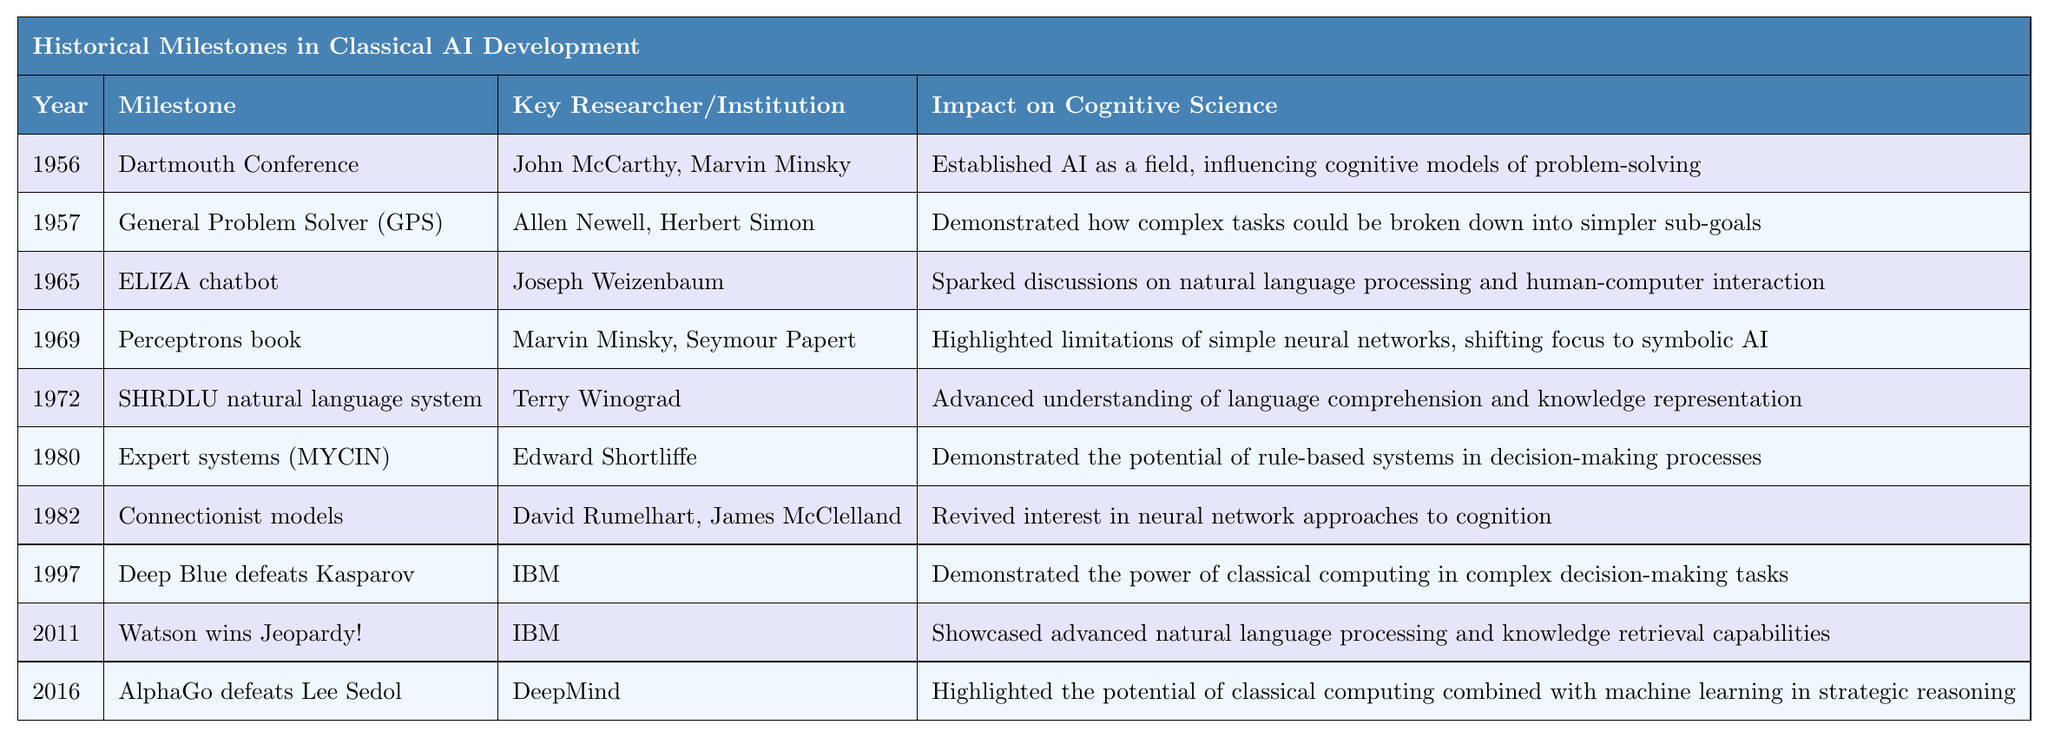What year did the Dartmouth Conference take place? The table provides a direct entry for the Dartmouth Conference, which notes that it took place in 1956 under the "Year" column.
Answer: 1956 Who were the key researchers behind the ELIZA chatbot? By looking at the "Key Researcher/Institution" column for the row with the "ELIZA chatbot" milestone, it shows that the key researchers were Joseph Weizenbaum.
Answer: Joseph Weizenbaum What impact did the Perceptrons book have on cognitive science? The "Impact on Cognitive Science" column for the "Perceptrons book" entry states that it highlighted the limitations of simple neural networks, which shifted the focus to symbolic AI.
Answer: Shifted focus to symbolic AI What percentage of milestones occurred before 1980? There are 5 milestones before 1980 (from the years 1956 to 1972) out of a total of 10 milestones. Calculating the percentage: (5/10) * 100 = 50%.
Answer: 50% Did the SHRDULU natural language system contribute to understanding language comprehension? The entry under "Impact on Cognitive Science" for SHRDLU confirms that it advanced the understanding of language comprehension. This means the statement is true.
Answer: Yes What is the difference in years between the development of the General Problem Solver and the ELIZA chatbot? The General Problem Solver was developed in 1957, and ELIZA was developed in 1965. The difference is 1965 - 1957 = 8 years.
Answer: 8 years List the key researchers who contributed to Expert systems. The table shows that Edward Shortliffe was the key researcher for the Expert systems milestone (MYCIN).
Answer: Edward Shortliffe What was the common theme among milestones from 1982 to 2016? The milestones from 1982 to 2016 relate to increasing complexity in cognitive tasks involving natural language processing, decision-making, and strategic reasoning, showcasing advancements in the capabilities of AI through classical computing.
Answer: Advancements in cognitive tasks and AI capabilities How many milestones were associated with IBM as the key institution? By reviewing the "Key Researcher/Institution" column, IBM is listed for two milestones: Deep Blue defeats Kasparov (1997) and Watson wins Jeopardy! (2011). Thus, there are 2 milestones.
Answer: 2 milestones What milestone introduced the concept of rule-based systems for decision-making? The milestone mentioned in the table that introduced rule-based systems is the Expert systems (MYCIN), as indicated in the "Milestone" column.
Answer: Expert systems (MYCIN) 